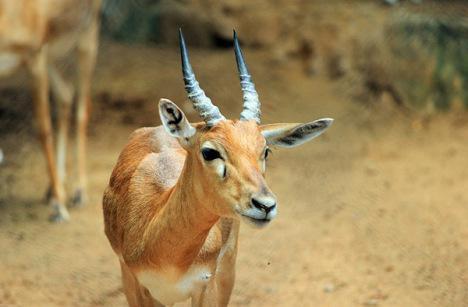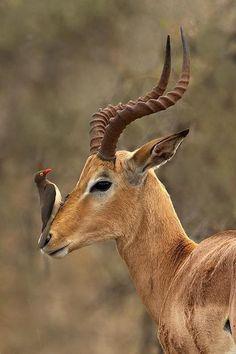The first image is the image on the left, the second image is the image on the right. For the images shown, is this caption "The animal in the image on the left is looking into the camera." true? Answer yes or no. No. 